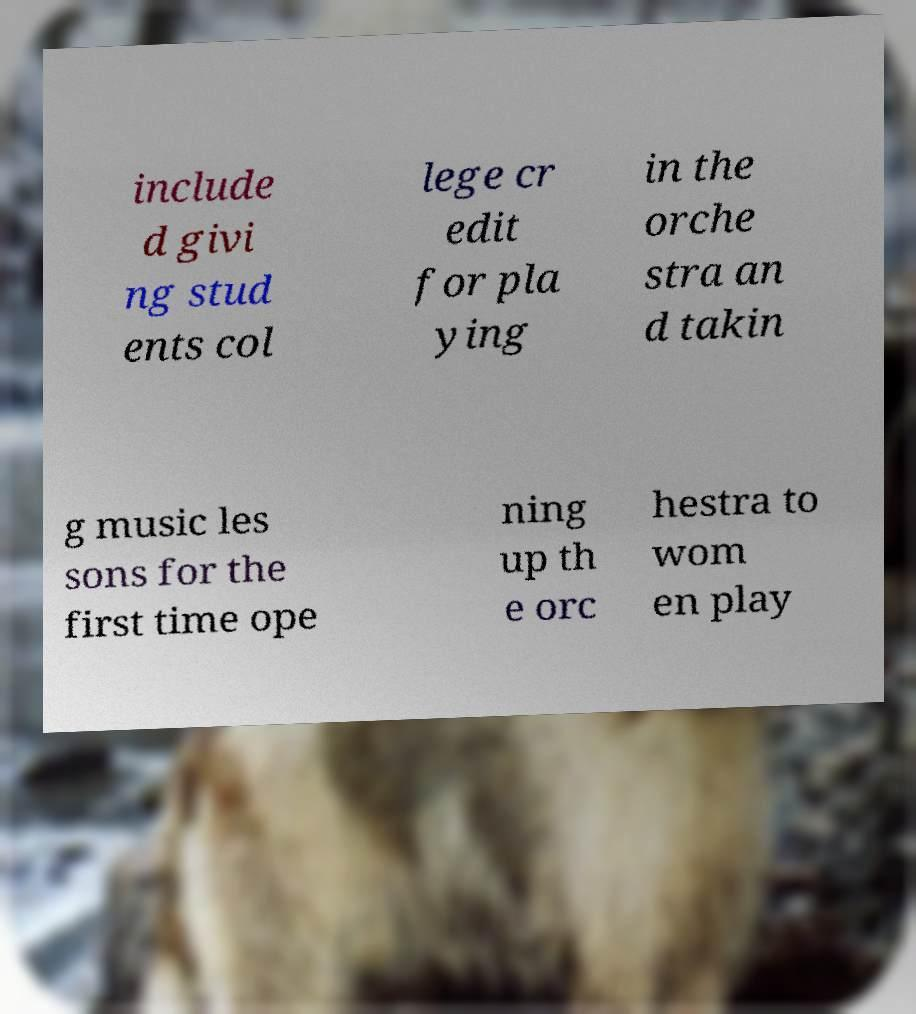Please read and relay the text visible in this image. What does it say? include d givi ng stud ents col lege cr edit for pla ying in the orche stra an d takin g music les sons for the first time ope ning up th e orc hestra to wom en play 